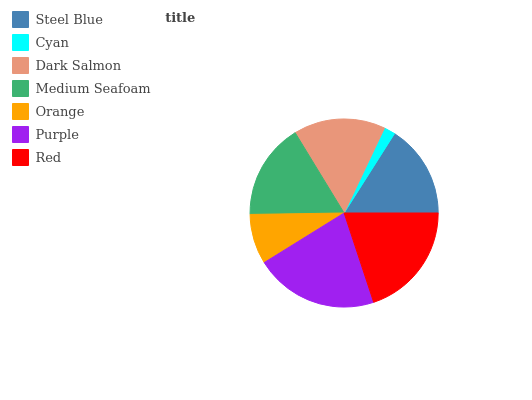Is Cyan the minimum?
Answer yes or no. Yes. Is Purple the maximum?
Answer yes or no. Yes. Is Dark Salmon the minimum?
Answer yes or no. No. Is Dark Salmon the maximum?
Answer yes or no. No. Is Dark Salmon greater than Cyan?
Answer yes or no. Yes. Is Cyan less than Dark Salmon?
Answer yes or no. Yes. Is Cyan greater than Dark Salmon?
Answer yes or no. No. Is Dark Salmon less than Cyan?
Answer yes or no. No. Is Steel Blue the high median?
Answer yes or no. Yes. Is Steel Blue the low median?
Answer yes or no. Yes. Is Red the high median?
Answer yes or no. No. Is Red the low median?
Answer yes or no. No. 